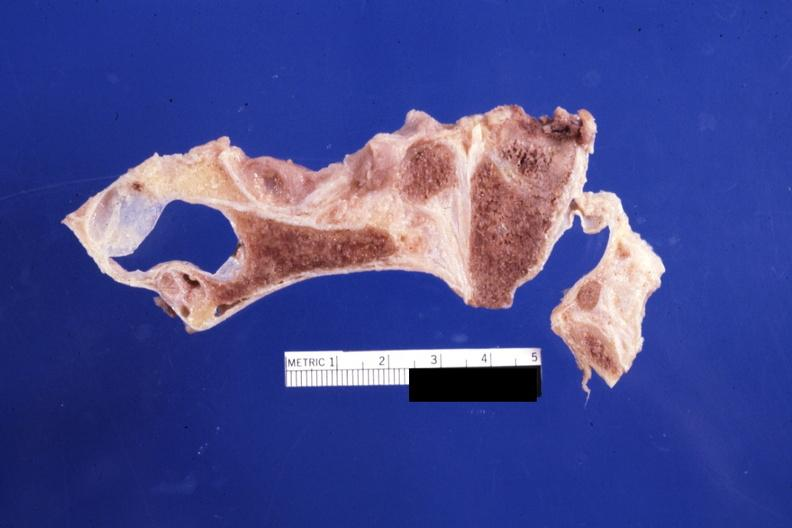s bone, calvarium present?
Answer the question using a single word or phrase. Yes 